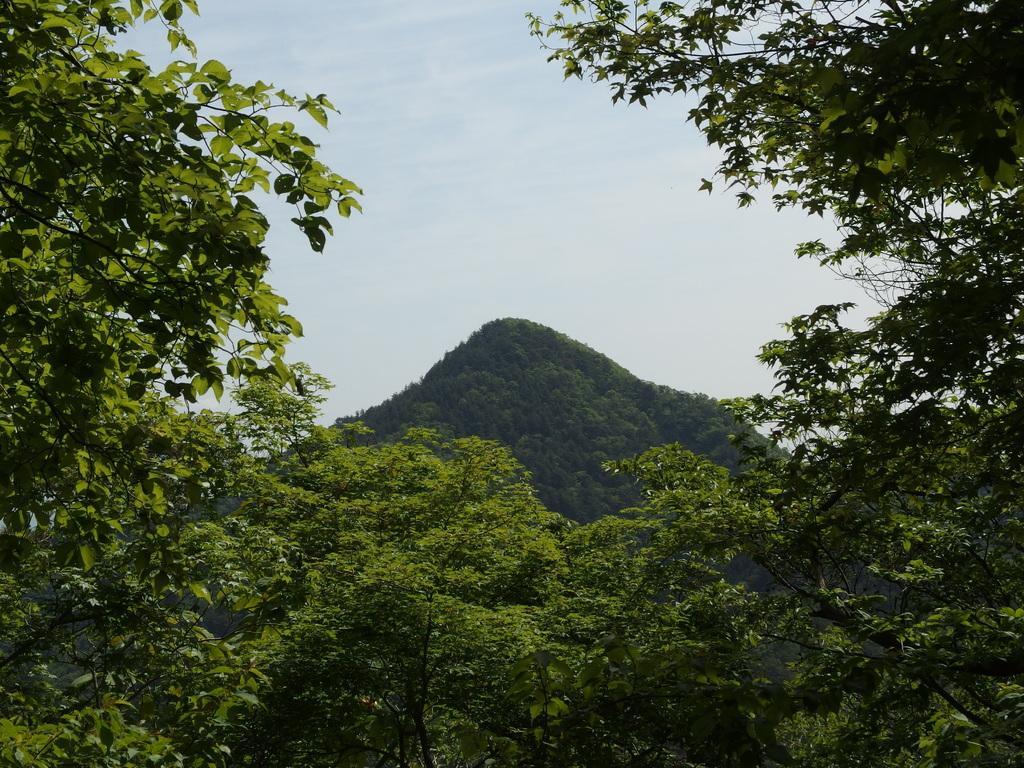Please provide a concise description of this image. In this picture we can see many trees. In the back there is a mountain. On the top we can see sky and clouds. 